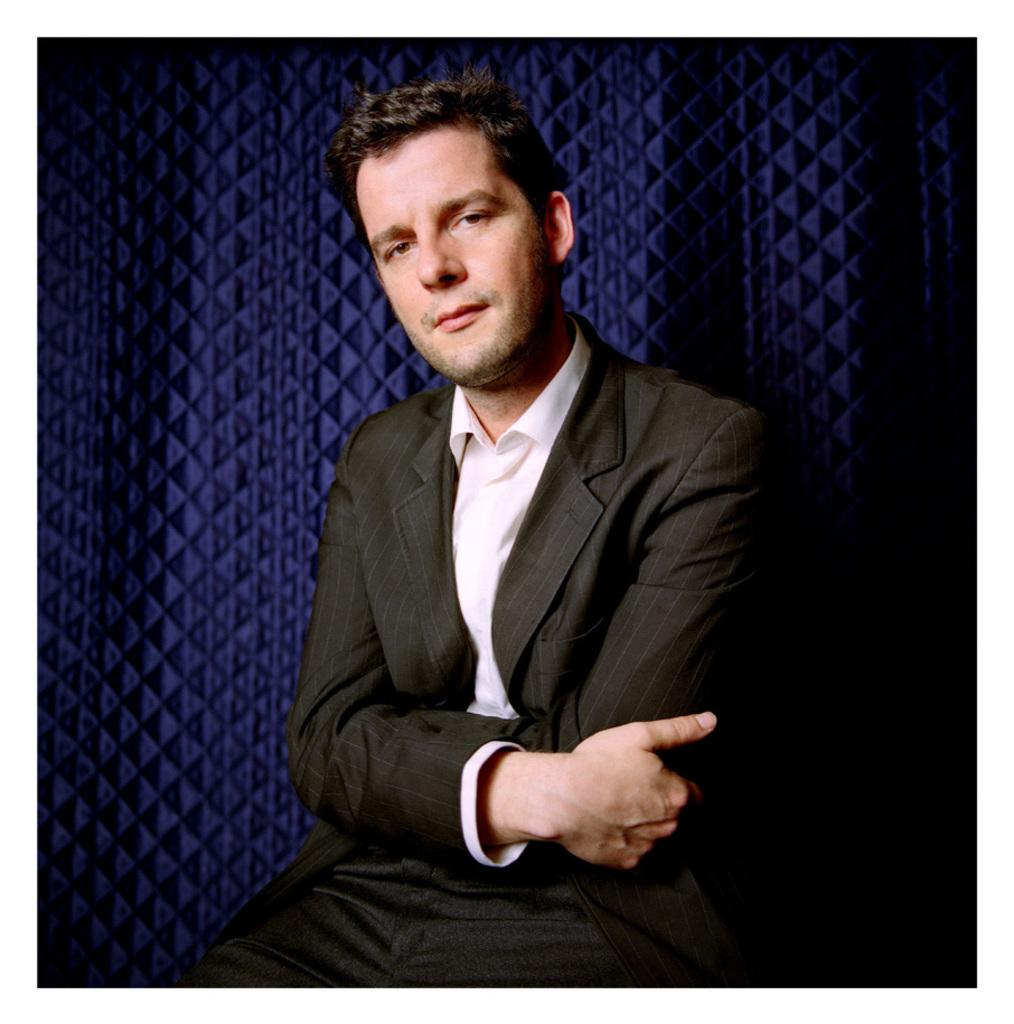Who or what is the main subject in the image? There is a person in the image. What is the person wearing? The person is wearing a white and black color dress. What color is the background of the image? The background of the image is purple. Can you tell me how many veins are visible on the person's hand in the image? There is no visible hand or veins in the image; the person's clothing is the main focus. Is the person's brother also present in the image? The facts provided do not mention the presence of a brother or any other person in the image. 